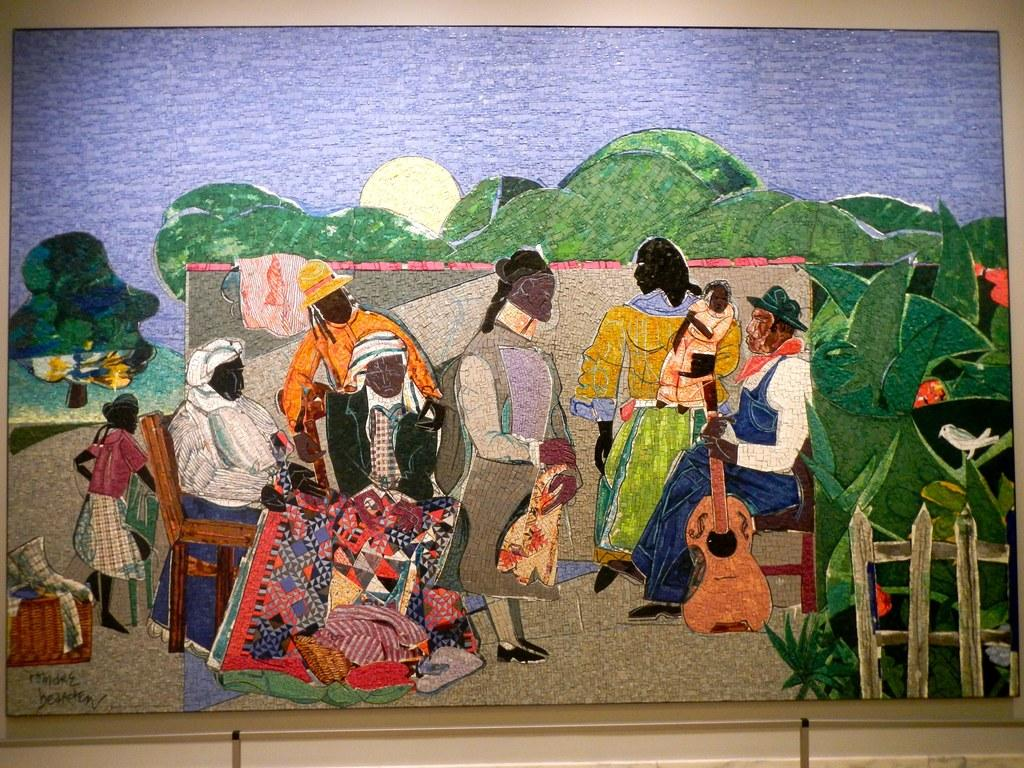What types of people are depicted in the painting? The painting contains men and women. What objects are present in the painting? The painting contains carpets, musical instruments, trees, a bird, a wooden grill, and a sun. What elements of the natural environment are depicted in the painting? The painting contains trees, sky, and ground. What type of ink is used to create the painting? The painting is not a physical object, but rather an image, so there is no ink used to create it. 